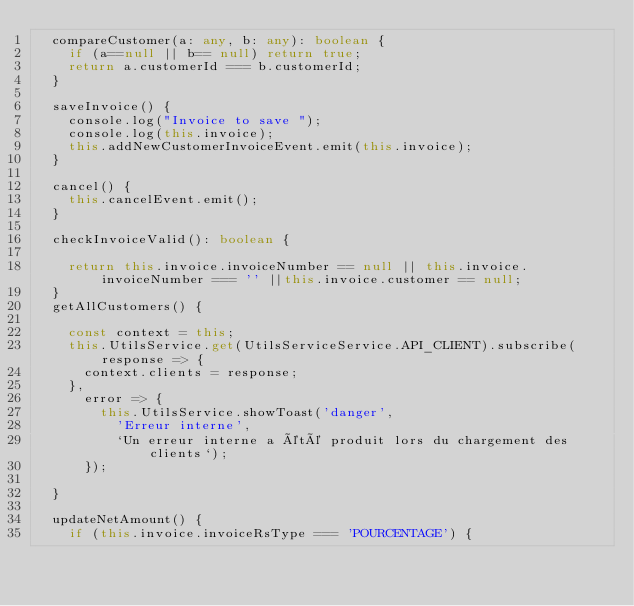<code> <loc_0><loc_0><loc_500><loc_500><_TypeScript_>  compareCustomer(a: any, b: any): boolean {
    if (a==null || b== null) return true;
    return a.customerId === b.customerId;
  }

  saveInvoice() {
    console.log("Invoice to save ");
    console.log(this.invoice);
    this.addNewCustomerInvoiceEvent.emit(this.invoice);
  }

  cancel() {
    this.cancelEvent.emit();
  }

  checkInvoiceValid(): boolean {

    return this.invoice.invoiceNumber == null || this.invoice.invoiceNumber === '' ||this.invoice.customer == null;
  }
  getAllCustomers() {

    const context = this;
    this.UtilsService.get(UtilsServiceService.API_CLIENT).subscribe(response => {
      context.clients = response;
    },
      error => {
        this.UtilsService.showToast('danger',
          'Erreur interne',
          `Un erreur interne a été produit lors du chargement des clients`);
      });

  }

  updateNetAmount() {
    if (this.invoice.invoiceRsType === 'POURCENTAGE') {</code> 